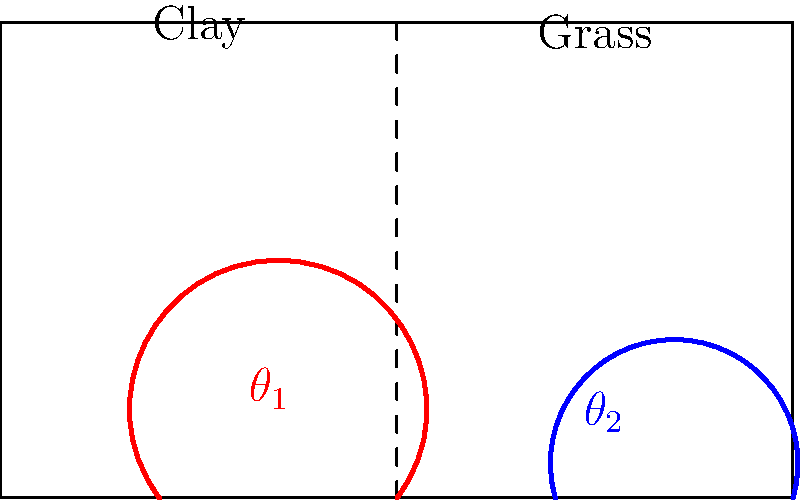Based on the diagram showing ball bounces on clay and grass courts, which surface typically produces a higher angle of bounce, and how does this affect gameplay? To answer this question, let's analyze the diagram and consider the properties of different tennis court surfaces:

1. Observe the diagram:
   - The red path represents the ball bounce on clay (left side).
   - The blue path represents the ball bounce on grass (right side).

2. Compare the angles:
   - $\theta_1$ (clay) appears larger than $\theta_2$ (grass).

3. Understand surface properties:
   - Clay is a slower surface with more friction.
   - Grass is a faster surface with less friction.

4. Effect on ball bounce:
   - Clay: The ball slows down more on impact, resulting in a higher bounce angle.
   - Grass: The ball maintains more of its speed, resulting in a lower bounce angle.

5. Impact on gameplay:
   - Clay: Higher bounces lead to longer rallies and favor baseline play.
   - Grass: Lower bounces promote faster gameplay and serve-and-volley tactics.

6. Historical context:
   - Different playing styles have evolved to suit various surfaces.
   - Players like Rafael Nadal have dominated on clay due to their ability to exploit the high bounces.
   - Players like Pete Sampras excelled on grass with powerful serves and quick net approaches.

Therefore, clay typically produces a higher angle of bounce compared to grass, significantly influencing playing styles and strategies on each surface.
Answer: Clay; higher bounces favor baseline play, while lower bounces on grass promote faster gameplay and serve-and-volley tactics. 